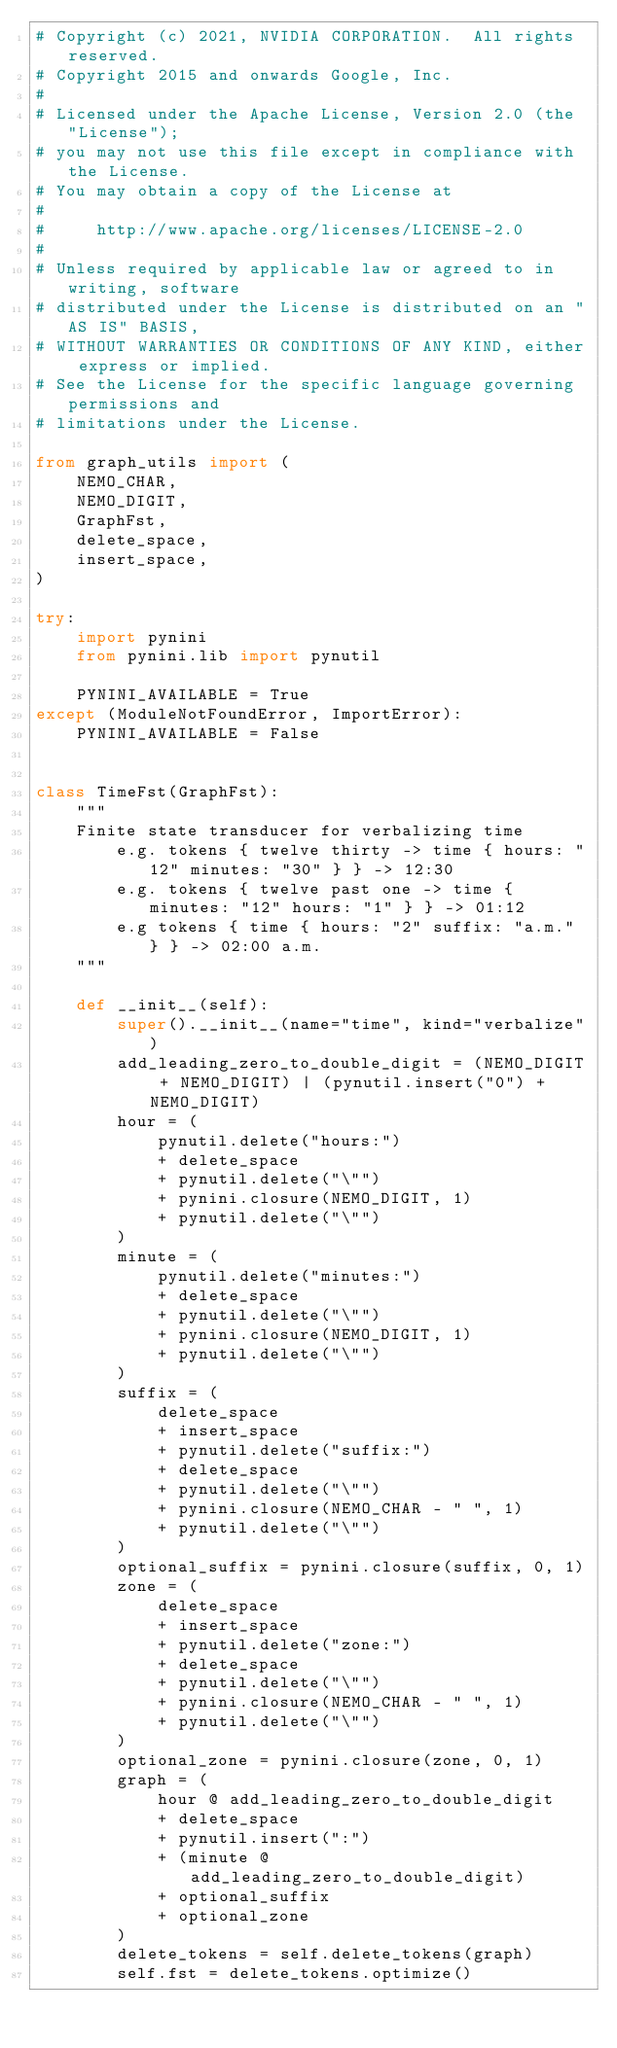Convert code to text. <code><loc_0><loc_0><loc_500><loc_500><_Python_># Copyright (c) 2021, NVIDIA CORPORATION.  All rights reserved.
# Copyright 2015 and onwards Google, Inc.
#
# Licensed under the Apache License, Version 2.0 (the "License");
# you may not use this file except in compliance with the License.
# You may obtain a copy of the License at
#
#     http://www.apache.org/licenses/LICENSE-2.0
#
# Unless required by applicable law or agreed to in writing, software
# distributed under the License is distributed on an "AS IS" BASIS,
# WITHOUT WARRANTIES OR CONDITIONS OF ANY KIND, either express or implied.
# See the License for the specific language governing permissions and
# limitations under the License.

from graph_utils import (
    NEMO_CHAR,
    NEMO_DIGIT,
    GraphFst,
    delete_space,
    insert_space,
)

try:
    import pynini
    from pynini.lib import pynutil

    PYNINI_AVAILABLE = True
except (ModuleNotFoundError, ImportError):
    PYNINI_AVAILABLE = False


class TimeFst(GraphFst):
    """
    Finite state transducer for verbalizing time
        e.g. tokens { twelve thirty -> time { hours: "12" minutes: "30" } } -> 12:30
        e.g. tokens { twelve past one -> time { minutes: "12" hours: "1" } } -> 01:12
        e.g tokens { time { hours: "2" suffix: "a.m." } } -> 02:00 a.m.
    """

    def __init__(self):
        super().__init__(name="time", kind="verbalize")
        add_leading_zero_to_double_digit = (NEMO_DIGIT + NEMO_DIGIT) | (pynutil.insert("0") + NEMO_DIGIT)
        hour = (
            pynutil.delete("hours:")
            + delete_space
            + pynutil.delete("\"")
            + pynini.closure(NEMO_DIGIT, 1)
            + pynutil.delete("\"")
        )
        minute = (
            pynutil.delete("minutes:")
            + delete_space
            + pynutil.delete("\"")
            + pynini.closure(NEMO_DIGIT, 1)
            + pynutil.delete("\"")
        )
        suffix = (
            delete_space
            + insert_space
            + pynutil.delete("suffix:")
            + delete_space
            + pynutil.delete("\"")
            + pynini.closure(NEMO_CHAR - " ", 1)
            + pynutil.delete("\"")
        )
        optional_suffix = pynini.closure(suffix, 0, 1)
        zone = (
            delete_space
            + insert_space
            + pynutil.delete("zone:")
            + delete_space
            + pynutil.delete("\"")
            + pynini.closure(NEMO_CHAR - " ", 1)
            + pynutil.delete("\"")
        )
        optional_zone = pynini.closure(zone, 0, 1)
        graph = (
            hour @ add_leading_zero_to_double_digit
            + delete_space
            + pynutil.insert(":")
            + (minute @ add_leading_zero_to_double_digit)
            + optional_suffix
            + optional_zone
        )
        delete_tokens = self.delete_tokens(graph)
        self.fst = delete_tokens.optimize()
</code> 